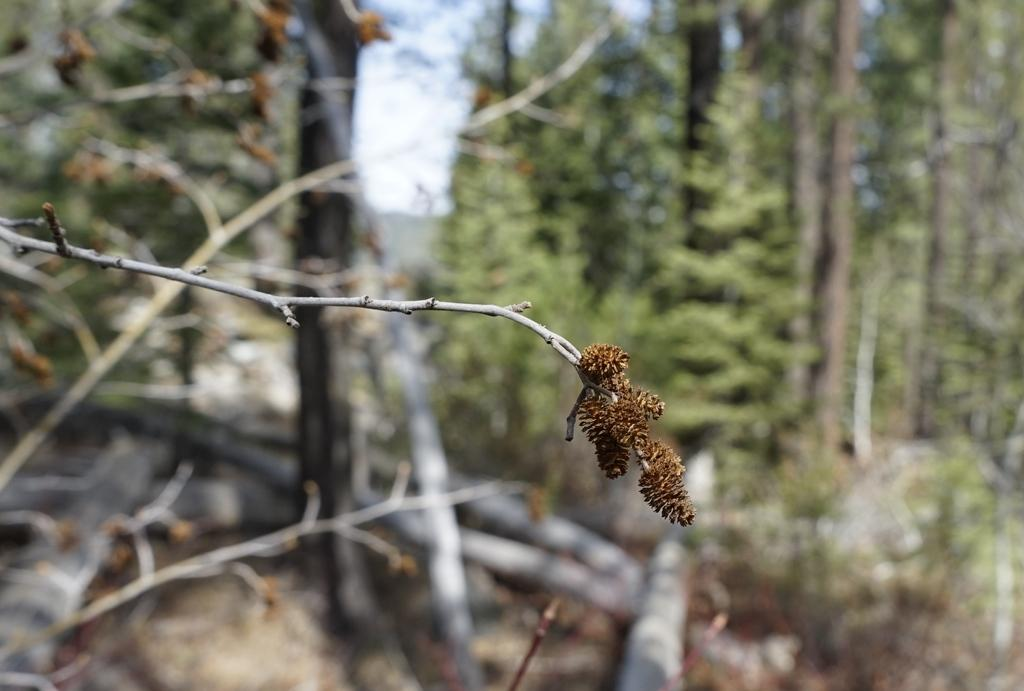What color is the object in the image? The object in the image is brown in color. What can be seen coming from the object in the image? Steam is visible in the image. What type of vegetation is present at the top of the image? There are trees at the top of the image. What is the color of the trees in the image? The trees in the image are blue in color. What type of beast can be seen behaving strangely in the image? There is no beast present in the image, and therefore no behavior can be observed. What type of chair is visible in the image? There is no chair present in the image. 